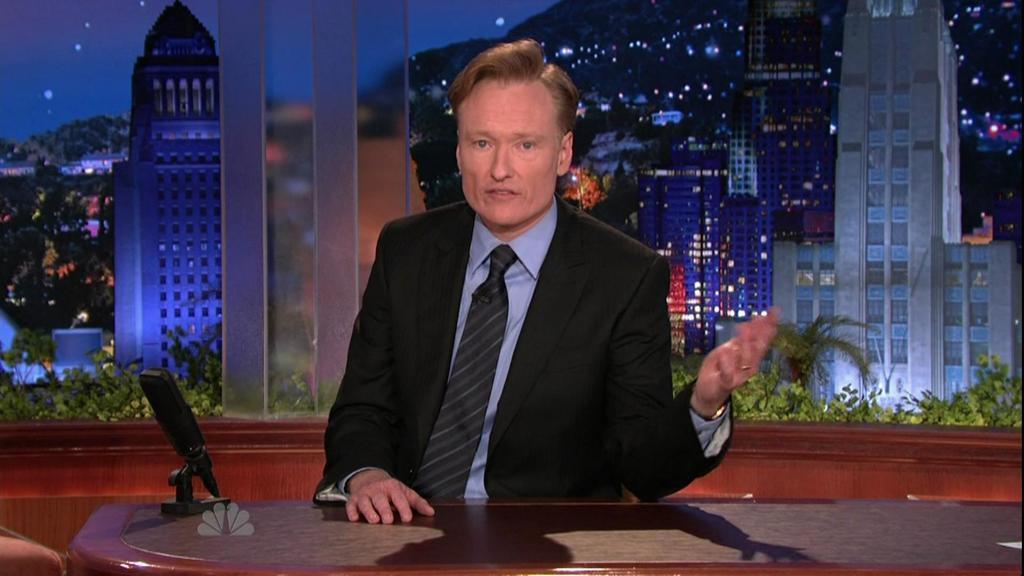How would you summarize this image in a sentence or two? In this image there is a person sitting before a table having microphone on it. He is wearing suit and tie. Behind him there are few plants. Behind it there are few builds and trees. Top of image there is sky. 